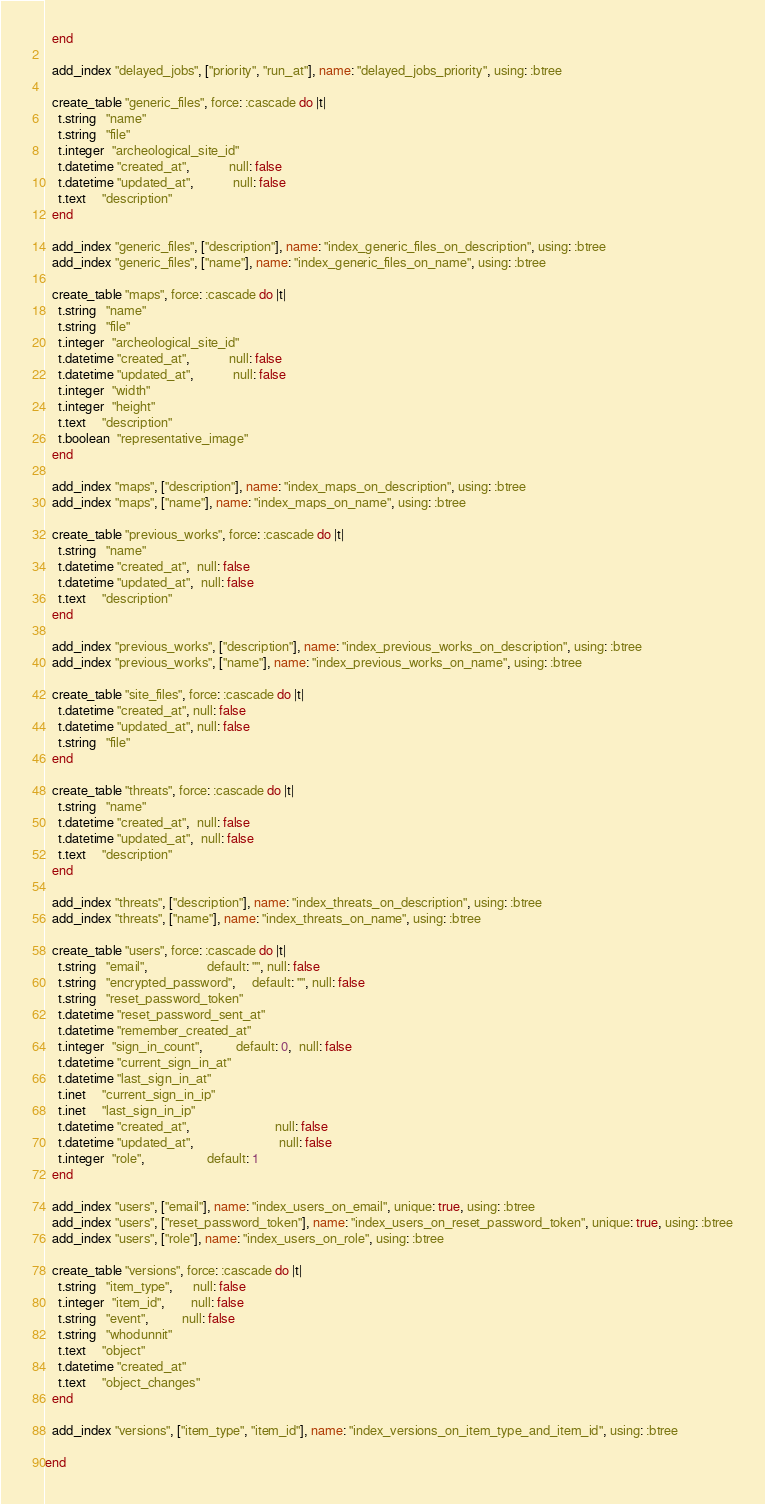<code> <loc_0><loc_0><loc_500><loc_500><_Ruby_>  end

  add_index "delayed_jobs", ["priority", "run_at"], name: "delayed_jobs_priority", using: :btree

  create_table "generic_files", force: :cascade do |t|
    t.string   "name"
    t.string   "file"
    t.integer  "archeological_site_id"
    t.datetime "created_at",            null: false
    t.datetime "updated_at",            null: false
    t.text     "description"
  end

  add_index "generic_files", ["description"], name: "index_generic_files_on_description", using: :btree
  add_index "generic_files", ["name"], name: "index_generic_files_on_name", using: :btree

  create_table "maps", force: :cascade do |t|
    t.string   "name"
    t.string   "file"
    t.integer  "archeological_site_id"
    t.datetime "created_at",            null: false
    t.datetime "updated_at",            null: false
    t.integer  "width"
    t.integer  "height"
    t.text     "description"
    t.boolean  "representative_image"
  end

  add_index "maps", ["description"], name: "index_maps_on_description", using: :btree
  add_index "maps", ["name"], name: "index_maps_on_name", using: :btree

  create_table "previous_works", force: :cascade do |t|
    t.string   "name"
    t.datetime "created_at",  null: false
    t.datetime "updated_at",  null: false
    t.text     "description"
  end

  add_index "previous_works", ["description"], name: "index_previous_works_on_description", using: :btree
  add_index "previous_works", ["name"], name: "index_previous_works_on_name", using: :btree

  create_table "site_files", force: :cascade do |t|
    t.datetime "created_at", null: false
    t.datetime "updated_at", null: false
    t.string   "file"
  end

  create_table "threats", force: :cascade do |t|
    t.string   "name"
    t.datetime "created_at",  null: false
    t.datetime "updated_at",  null: false
    t.text     "description"
  end

  add_index "threats", ["description"], name: "index_threats_on_description", using: :btree
  add_index "threats", ["name"], name: "index_threats_on_name", using: :btree

  create_table "users", force: :cascade do |t|
    t.string   "email",                  default: "", null: false
    t.string   "encrypted_password",     default: "", null: false
    t.string   "reset_password_token"
    t.datetime "reset_password_sent_at"
    t.datetime "remember_created_at"
    t.integer  "sign_in_count",          default: 0,  null: false
    t.datetime "current_sign_in_at"
    t.datetime "last_sign_in_at"
    t.inet     "current_sign_in_ip"
    t.inet     "last_sign_in_ip"
    t.datetime "created_at",                          null: false
    t.datetime "updated_at",                          null: false
    t.integer  "role",                   default: 1
  end

  add_index "users", ["email"], name: "index_users_on_email", unique: true, using: :btree
  add_index "users", ["reset_password_token"], name: "index_users_on_reset_password_token", unique: true, using: :btree
  add_index "users", ["role"], name: "index_users_on_role", using: :btree

  create_table "versions", force: :cascade do |t|
    t.string   "item_type",      null: false
    t.integer  "item_id",        null: false
    t.string   "event",          null: false
    t.string   "whodunnit"
    t.text     "object"
    t.datetime "created_at"
    t.text     "object_changes"
  end

  add_index "versions", ["item_type", "item_id"], name: "index_versions_on_item_type_and_item_id", using: :btree

end
</code> 